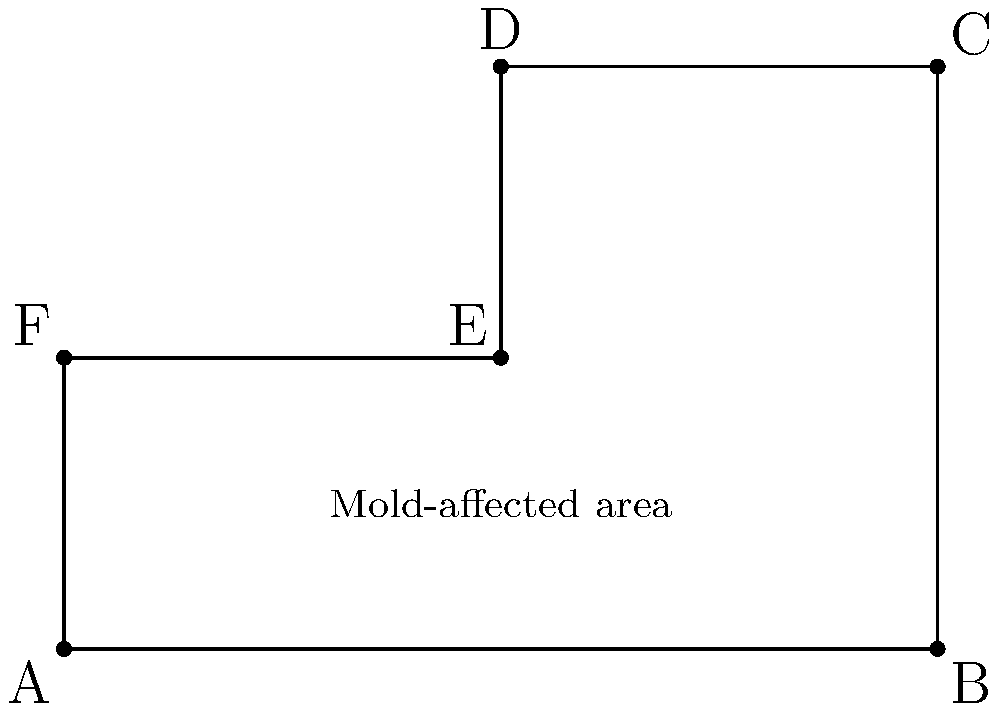A rectangular floor plan of a house is represented in a coordinate system where each unit equals 1 meter. Mold damage has been detected in a polygonal area with vertices at A(0,0), B(6,0), C(6,4), D(3,4), E(3,2), and F(0,2). Calculate the total area of the mold-affected region in square meters. To calculate the area of the mold-affected region, we can divide the polygon into two rectangles:

1. Rectangle ABEF:
   Width = $6 - 0 = 6$ meters
   Height = $2 - 0 = 2$ meters
   Area of ABEF = $6 \times 2 = 12$ square meters

2. Rectangle ECDF:
   Width = $3 - 0 = 3$ meters
   Height = $4 - 2 = 2$ meters
   Area of ECDF = $3 \times 2 = 6$ square meters

3. Total area:
   Total area = Area of ABEF + Area of ECDF
   $$ \text{Total area} = 12 + 6 = 18 \text{ square meters} $$

Therefore, the total area of the mold-affected region is 18 square meters.
Answer: 18 square meters 